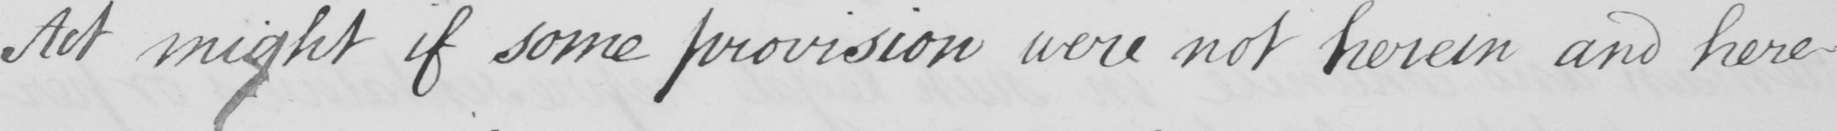Can you read and transcribe this handwriting? Act might if some provision were not herein and here- 